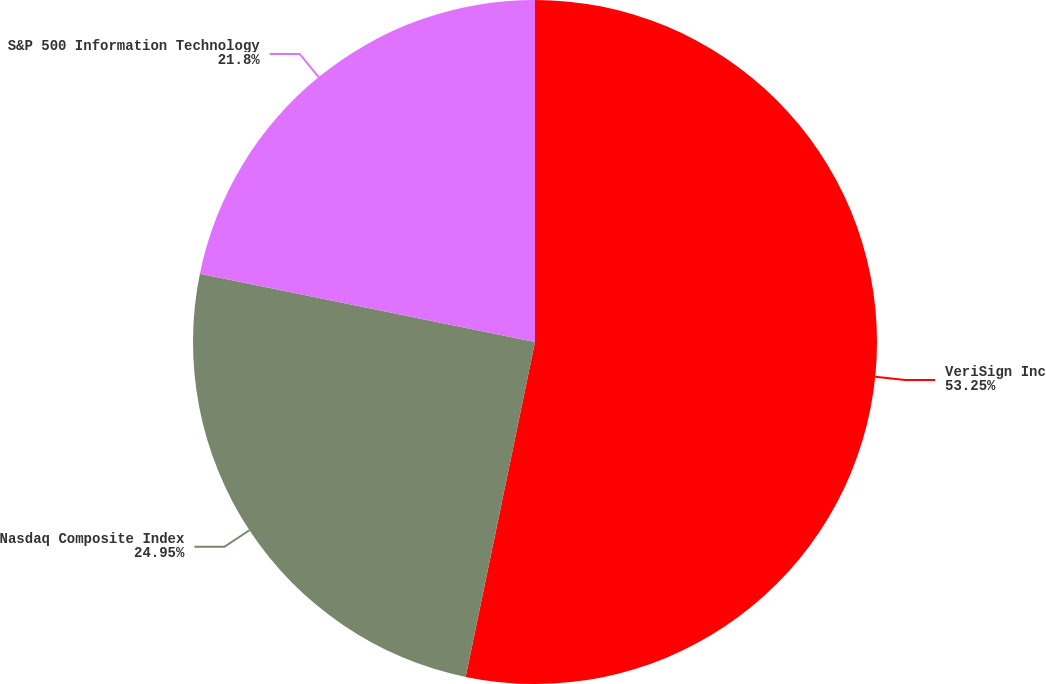Convert chart. <chart><loc_0><loc_0><loc_500><loc_500><pie_chart><fcel>VeriSign Inc<fcel>Nasdaq Composite Index<fcel>S&P 500 Information Technology<nl><fcel>53.25%<fcel>24.95%<fcel>21.8%<nl></chart> 